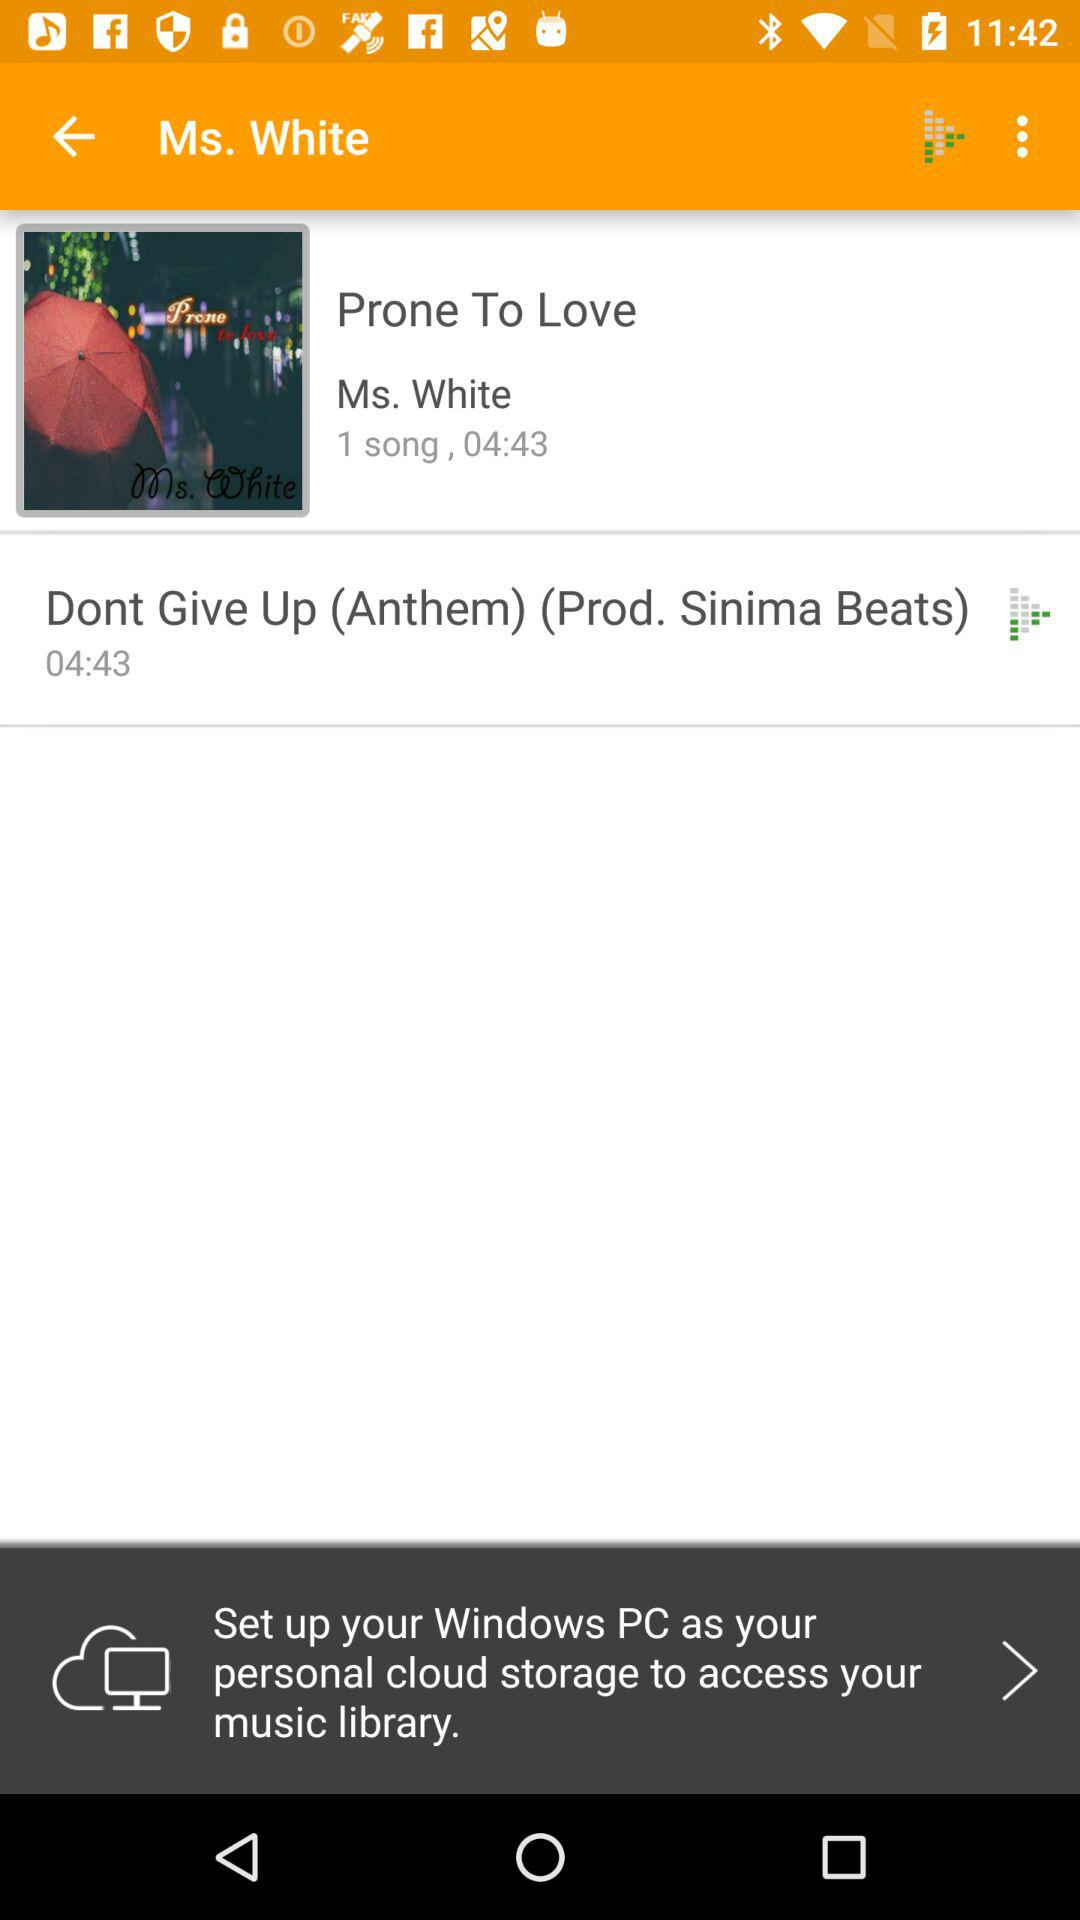What is the artist name of the album? The artist name of the album is Ms. White. 